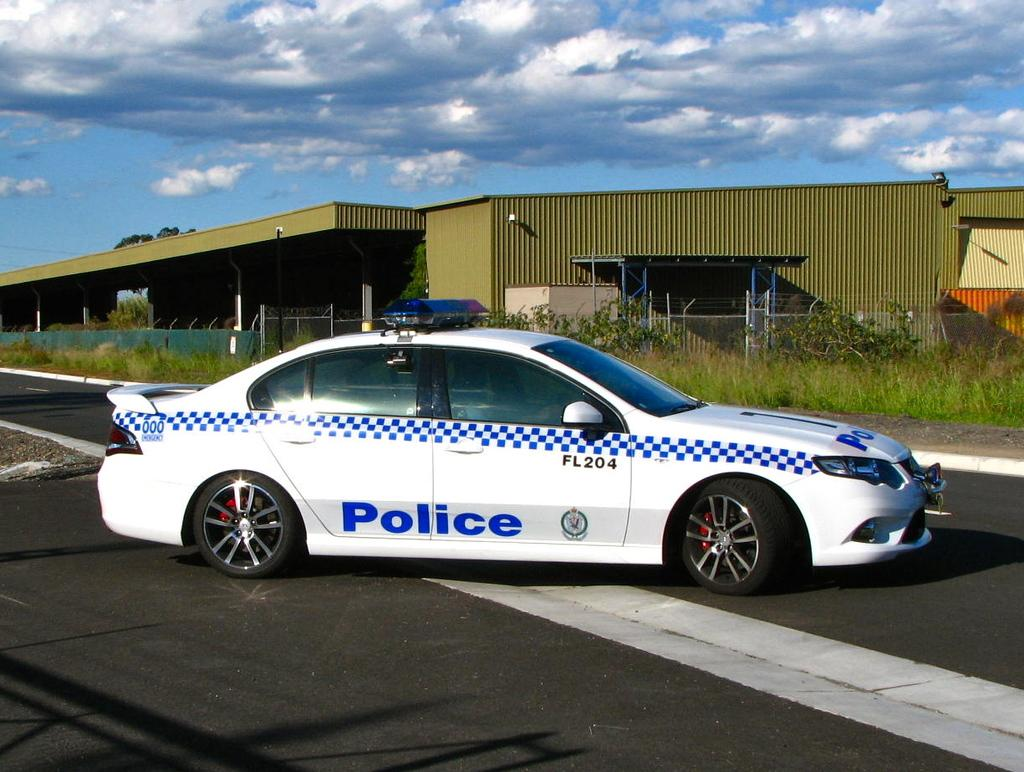What type of vehicle is in the image? There is a police car in the image. Where is the police car located? The police car is placed on the road. What can be seen in the background of the image? There is a group of plants and at least one building in the background of the image. What part of the natural environment is visible in the image? The sky is visible in the background of the image. How many locks are visible on the police car in the image? There are no locks visible on the police car in the image. What type of tail is attached to the police car in the image? There is no tail attached to the police car in the image. 